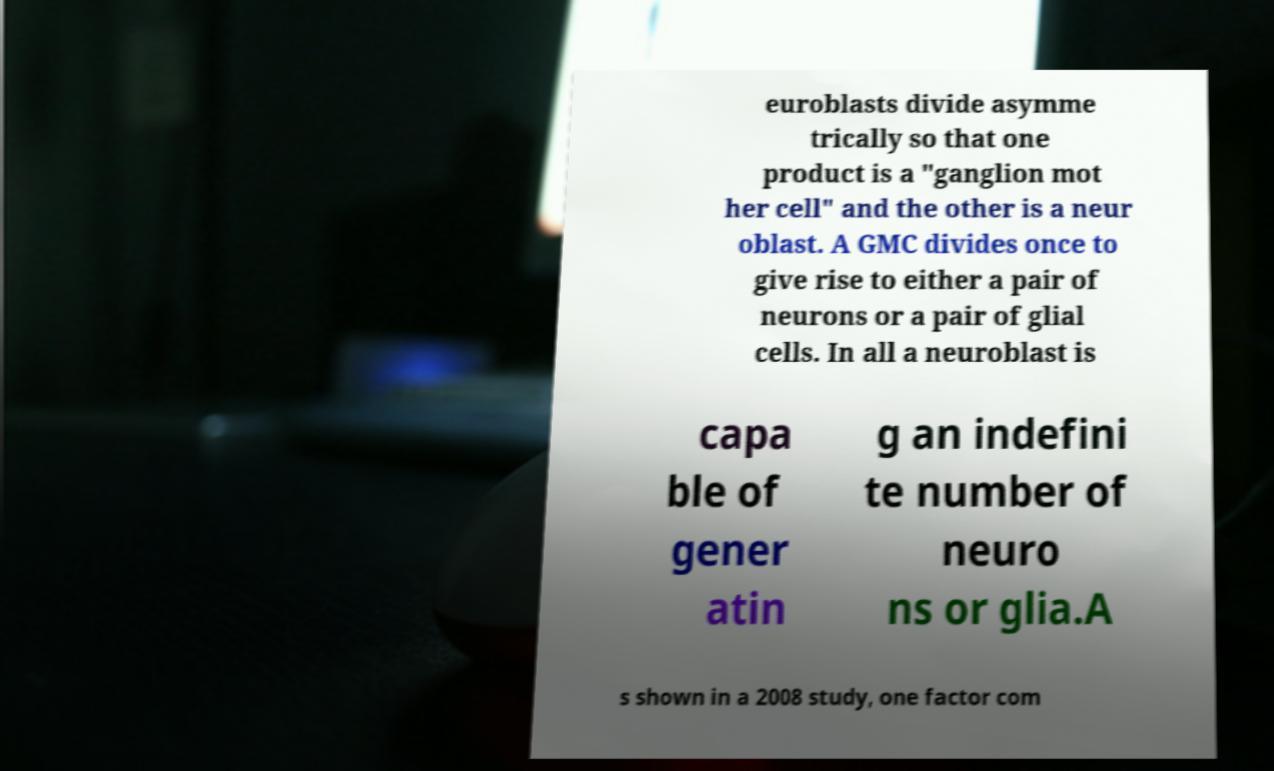Could you extract and type out the text from this image? euroblasts divide asymme trically so that one product is a "ganglion mot her cell" and the other is a neur oblast. A GMC divides once to give rise to either a pair of neurons or a pair of glial cells. In all a neuroblast is capa ble of gener atin g an indefini te number of neuro ns or glia.A s shown in a 2008 study, one factor com 